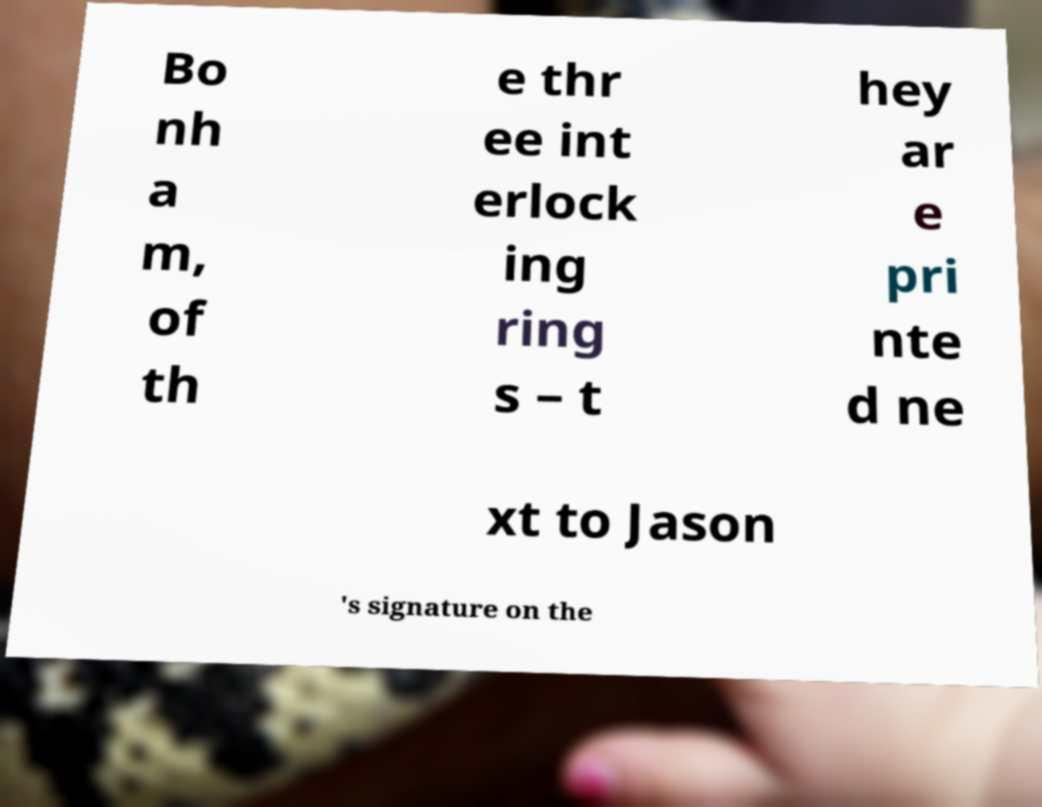Please identify and transcribe the text found in this image. Bo nh a m, of th e thr ee int erlock ing ring s – t hey ar e pri nte d ne xt to Jason 's signature on the 